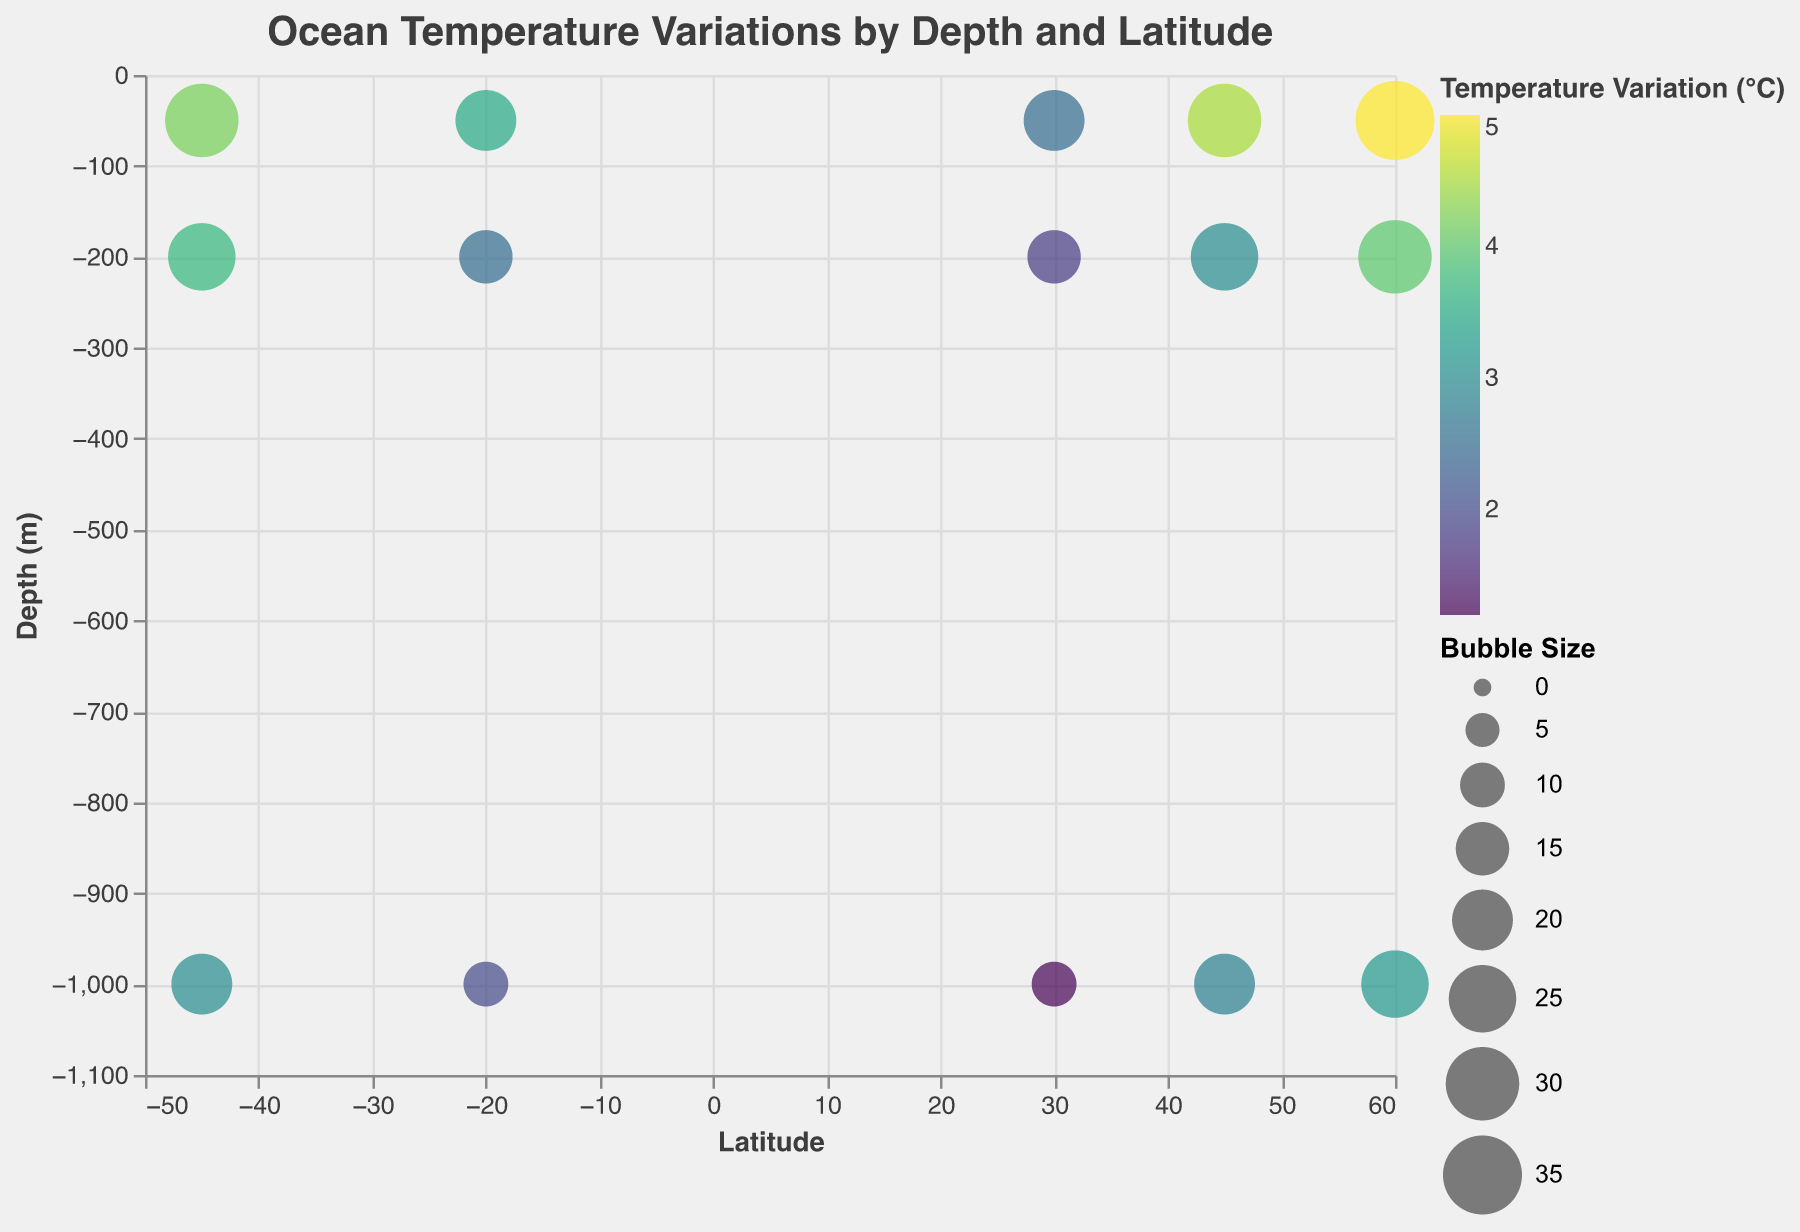What is the title of the figure? The title of the figure is prominently displayed at the top and reads "Ocean Temperature Variations by Depth and Latitude."
Answer: Ocean Temperature Variations by Depth and Latitude Which latitude shows the highest temperature variation at 50 meters depth? Look for the largest bubble at the depth of -50 meters; it corresponds to a latitude of 60 degrees.
Answer: 60 degrees What is the temperature variation at a depth of 1000 meters for latitude 30? Find the bubble that intersects latitude 30 and depth -1000 meters. The color code indicates a temperature variation of 1.2°C.
Answer: 1.2°C How does the temperature variation at 200 meters depth in latitude 45 compare with latitude -20? Compare the color intensities and sizes of bubbles at -200 meters for both latitudes. Latitude 45 has a temperature variation of 3.0°C, whereas latitude -20 has a lower variation of 2.5°C.
Answer: Higher in latitude 45 What is the trend in temperature variation as depth increases for latitude 60? Observe the bubbles at latitude 60 as depth goes from -50 to -1000 meters. The temperature variation decreases from 5.0°C at -50 meters to 3.2°C at -1000 meters.
Answer: Decreases Which depth shows the least variation in temperature at latitude 45? Compare the bubbles at latitude 45 across different depths. The smallest color intensity at -1000 meters shows a temperature variation of 2.8°C, which is the least.
Answer: 1000 meters What is the overall pattern of temperature variation by latitude at depths of 50 meters? Examine the bubbles at -50 meters for all latitudes. Higher latitudes generally show higher temperature variations.
Answer: Higher latitudes have higher variation Between latitude -45 and 45 at 200 meters depth, which one has the higher temperature variation? Compare bubbles for both latitudes at -200 meters. Latitude -45 has a variation of 3.7°C, higher than 3.0°C for latitude 45.
Answer: Latitude -45 How does the temperature variation at 200 meters depth in latitude 60 relate to its variation at 1000 meters depth? Examine the bubbles' sizes and color intensities for these depths. At -200 meters, the variation is 4.0°C, which is higher than the 3.2°C at -1000 meters.
Answer: Higher at 200 meters What is the deepest measurement depth shown in the figure, and which latitude does it correspond to? The maximum depth shown in the figure is -1000 meters, which appears for multiple latitudes including 45, 60, 30, -20, and -45.
Answer: -1000 meters for multiple latitudes 